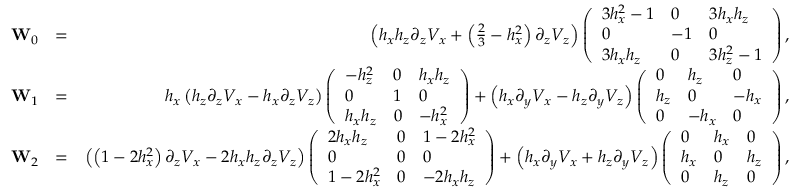Convert formula to latex. <formula><loc_0><loc_0><loc_500><loc_500>\begin{array} { r l r } { W _ { 0 } } & { = } & { \left ( h _ { x } h _ { z } \partial _ { z } V _ { x } + \left ( \frac { 2 } { 3 } - h _ { x } ^ { 2 } \right ) \partial _ { z } V _ { z } \right ) \left ( \begin{array} { l l l } { 3 h _ { x } ^ { 2 } - 1 } & { 0 } & { 3 h _ { x } h _ { z } } \\ { 0 } & { - 1 } & { 0 } \\ { 3 h _ { x } h _ { z } } & { 0 } & { 3 h _ { z } ^ { 2 } - 1 } \end{array} \right ) , } \\ { W _ { 1 } } & { = } & { h _ { x } \left ( h _ { z } \partial _ { z } V _ { x } - h _ { x } \partial _ { z } V _ { z } \right ) \left ( \begin{array} { l l l } { - h _ { z } ^ { 2 } } & { 0 } & { h _ { x } h _ { z } } \\ { 0 } & { 1 } & { 0 } \\ { h _ { x } h _ { z } } & { 0 } & { - h _ { x } ^ { 2 } } \end{array} \right ) + \left ( h _ { x } \partial _ { y } V _ { x } - h _ { z } \partial _ { y } V _ { z } \right ) \left ( \begin{array} { l l l } { 0 } & { h _ { z } } & { 0 } \\ { h _ { z } } & { 0 } & { - h _ { x } } \\ { 0 } & { - h _ { x } } & { 0 } \end{array} \right ) , } \\ { W _ { 2 } } & { = } & { \left ( \left ( 1 - 2 h _ { x } ^ { 2 } \right ) \partial _ { z } V _ { x } - 2 h _ { x } h _ { z } \partial _ { z } V _ { z } \right ) \left ( \begin{array} { l l l } { 2 h _ { x } h _ { z } } & { 0 } & { 1 - 2 h _ { x } ^ { 2 } } \\ { 0 } & { 0 } & { 0 } \\ { 1 - 2 h _ { x } ^ { 2 } } & { 0 } & { - 2 h _ { x } h _ { z } } \end{array} \right ) + \left ( h _ { x } \partial _ { y } V _ { x } + h _ { z } \partial _ { y } V _ { z } \right ) \left ( \begin{array} { l l l } { 0 } & { h _ { x } } & { 0 } \\ { h _ { x } } & { 0 } & { h _ { z } } \\ { 0 } & { h _ { z } } & { 0 } \end{array} \right ) , } \end{array}</formula> 